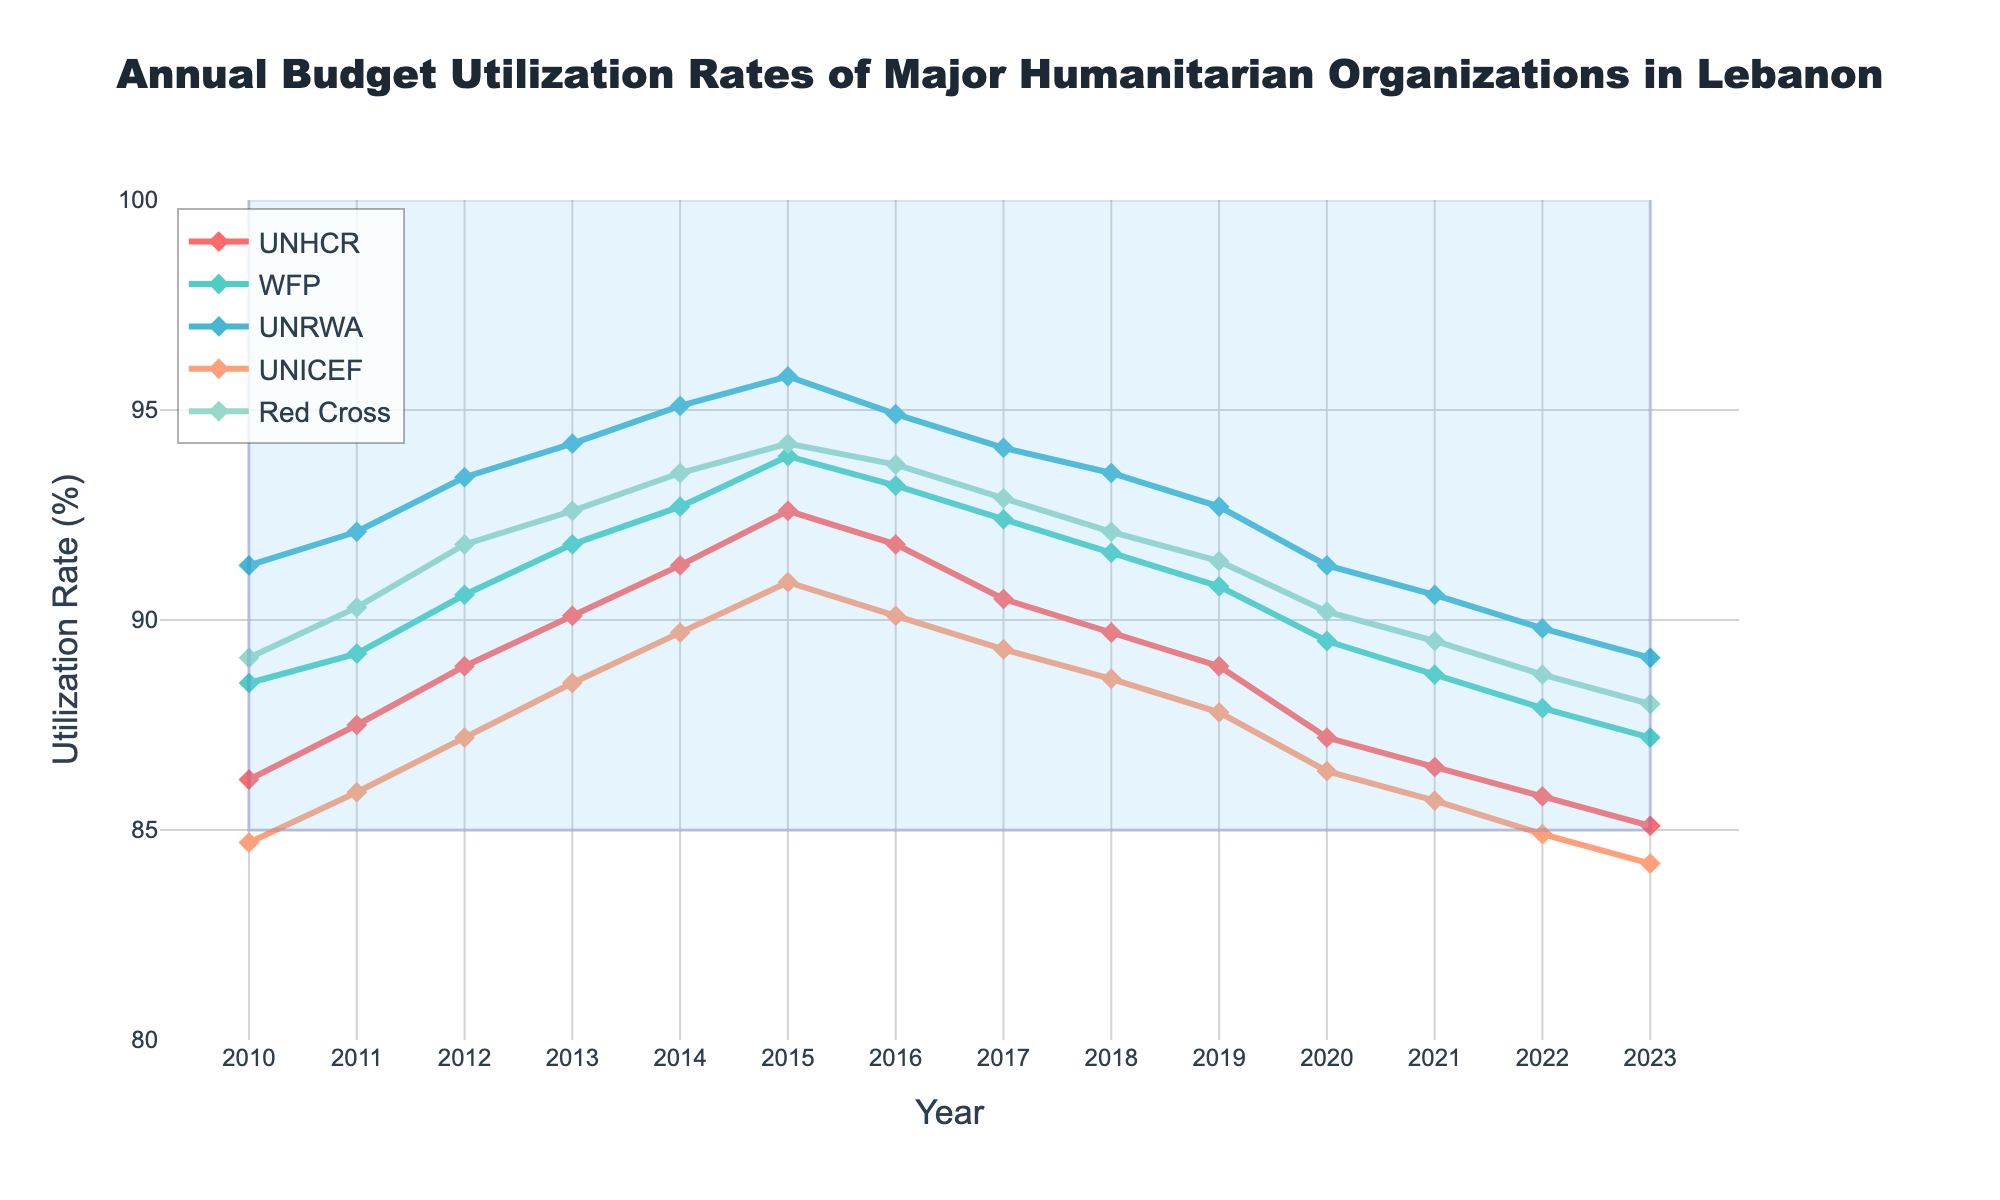What years did UNHCR have the highest budget utilization rate? To determine this, identify the peak point in the line graph for UNHCR. By tracing the line, we find that the highest point for UNHCR is in 2015.
Answer: 2015 Which organization had the highest budget utilization rate in 2023? Compare the data points for all organizations in 2023 by looking at the line markers and labels. UNRWA has the highest rate at 89.1%.
Answer: UNRWA How did UNICEF's budget utilization rate change from 2010 to 2023? Looking at UNICEF's line from the start year to the end year, observe the general trend. The rate decreased from 84.7% in 2010 to 84.2% in 2023.
Answer: Decreased Which organization showed the most consistent budget utilization rate over the years? By comparing the fluctuation ranges of all lines, UNRWA exhibits the smallest changes over the years.
Answer: UNRWA What is the average budget utilization rate for WFP from 2010 to 2023? Sum all annual utilization rates for WFP from 2010 to 2023, then divide by the number of years. The result is \((88.5 + 89.2 + 90.6 + 91.8 + 92.7 + 93.9 + 93.2 + 92.4 + 91.6 + 90.8 + 89.5 + 88.7 + 87.9 + 87.2) / 14\). After calculating, the average is approximately 90.55%.
Answer: Approximately 90.55% During which year did the Red Cross have the same budget utilization rate as UNICEF? By visually inspecting the intersection points of the Red Cross and UNICEF lines or comparing the data points, we see both organizations had the same rate of 84.2% in 2023.
Answer: 2023 Are there any years where all organizations' budget utilization rates fell below 90%? Scan through the plot and check each year for data points below 90%. In 2022 and 2023, no organization had a budget utilization rate above 90%.
Answer: 2022, 2023 Does WFP's budget utilization rate ever drop below UNHCR's rate? Compare the WFP and UNHCR lines year by year. WFP's line stays above UNHCR's at all times.
Answer: No Has the budget utilization rate for the Red Cross ever been the highest among all organizations in any year? Visually compare all the lines for each year. From 2010 to 2023, the Red Cross never had the highest rate.
Answer: No 